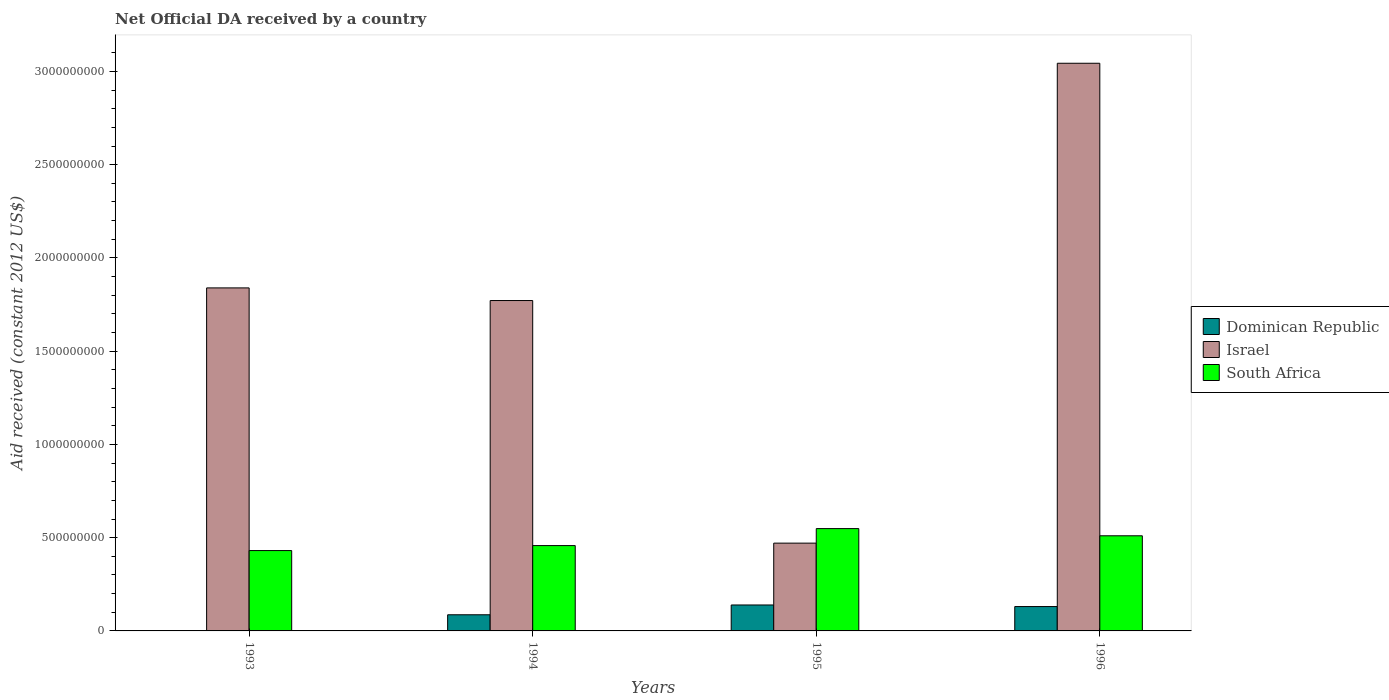How many different coloured bars are there?
Make the answer very short. 3. Are the number of bars per tick equal to the number of legend labels?
Your answer should be very brief. No. Are the number of bars on each tick of the X-axis equal?
Make the answer very short. No. How many bars are there on the 2nd tick from the right?
Your answer should be compact. 3. What is the label of the 4th group of bars from the left?
Give a very brief answer. 1996. In how many cases, is the number of bars for a given year not equal to the number of legend labels?
Give a very brief answer. 1. What is the net official development assistance aid received in Dominican Republic in 1993?
Your response must be concise. 0. Across all years, what is the maximum net official development assistance aid received in Dominican Republic?
Ensure brevity in your answer.  1.39e+08. What is the total net official development assistance aid received in South Africa in the graph?
Your answer should be very brief. 1.95e+09. What is the difference between the net official development assistance aid received in South Africa in 1995 and that in 1996?
Provide a short and direct response. 3.86e+07. What is the difference between the net official development assistance aid received in Dominican Republic in 1996 and the net official development assistance aid received in Israel in 1994?
Give a very brief answer. -1.64e+09. What is the average net official development assistance aid received in South Africa per year?
Provide a short and direct response. 4.87e+08. In the year 1996, what is the difference between the net official development assistance aid received in Israel and net official development assistance aid received in South Africa?
Give a very brief answer. 2.53e+09. What is the ratio of the net official development assistance aid received in South Africa in 1993 to that in 1994?
Ensure brevity in your answer.  0.94. What is the difference between the highest and the second highest net official development assistance aid received in South Africa?
Provide a succinct answer. 3.86e+07. What is the difference between the highest and the lowest net official development assistance aid received in South Africa?
Offer a very short reply. 1.18e+08. Is it the case that in every year, the sum of the net official development assistance aid received in Dominican Republic and net official development assistance aid received in Israel is greater than the net official development assistance aid received in South Africa?
Your answer should be very brief. Yes. Are the values on the major ticks of Y-axis written in scientific E-notation?
Your answer should be very brief. No. Does the graph contain any zero values?
Your answer should be very brief. Yes. Does the graph contain grids?
Give a very brief answer. No. Where does the legend appear in the graph?
Offer a terse response. Center right. How are the legend labels stacked?
Your answer should be compact. Vertical. What is the title of the graph?
Provide a succinct answer. Net Official DA received by a country. What is the label or title of the X-axis?
Your response must be concise. Years. What is the label or title of the Y-axis?
Make the answer very short. Aid received (constant 2012 US$). What is the Aid received (constant 2012 US$) of Dominican Republic in 1993?
Ensure brevity in your answer.  0. What is the Aid received (constant 2012 US$) of Israel in 1993?
Your answer should be very brief. 1.84e+09. What is the Aid received (constant 2012 US$) in South Africa in 1993?
Ensure brevity in your answer.  4.31e+08. What is the Aid received (constant 2012 US$) of Dominican Republic in 1994?
Your answer should be compact. 8.66e+07. What is the Aid received (constant 2012 US$) of Israel in 1994?
Keep it short and to the point. 1.77e+09. What is the Aid received (constant 2012 US$) of South Africa in 1994?
Provide a short and direct response. 4.58e+08. What is the Aid received (constant 2012 US$) of Dominican Republic in 1995?
Give a very brief answer. 1.39e+08. What is the Aid received (constant 2012 US$) of Israel in 1995?
Your answer should be compact. 4.71e+08. What is the Aid received (constant 2012 US$) in South Africa in 1995?
Offer a very short reply. 5.49e+08. What is the Aid received (constant 2012 US$) of Dominican Republic in 1996?
Your response must be concise. 1.31e+08. What is the Aid received (constant 2012 US$) of Israel in 1996?
Offer a very short reply. 3.04e+09. What is the Aid received (constant 2012 US$) in South Africa in 1996?
Provide a succinct answer. 5.10e+08. Across all years, what is the maximum Aid received (constant 2012 US$) in Dominican Republic?
Your answer should be very brief. 1.39e+08. Across all years, what is the maximum Aid received (constant 2012 US$) in Israel?
Your answer should be very brief. 3.04e+09. Across all years, what is the maximum Aid received (constant 2012 US$) in South Africa?
Give a very brief answer. 5.49e+08. Across all years, what is the minimum Aid received (constant 2012 US$) in Israel?
Your answer should be very brief. 4.71e+08. Across all years, what is the minimum Aid received (constant 2012 US$) in South Africa?
Provide a succinct answer. 4.31e+08. What is the total Aid received (constant 2012 US$) of Dominican Republic in the graph?
Offer a terse response. 3.56e+08. What is the total Aid received (constant 2012 US$) in Israel in the graph?
Your answer should be compact. 7.13e+09. What is the total Aid received (constant 2012 US$) in South Africa in the graph?
Your answer should be very brief. 1.95e+09. What is the difference between the Aid received (constant 2012 US$) in Israel in 1993 and that in 1994?
Provide a short and direct response. 6.78e+07. What is the difference between the Aid received (constant 2012 US$) of South Africa in 1993 and that in 1994?
Offer a terse response. -2.67e+07. What is the difference between the Aid received (constant 2012 US$) of Israel in 1993 and that in 1995?
Ensure brevity in your answer.  1.37e+09. What is the difference between the Aid received (constant 2012 US$) in South Africa in 1993 and that in 1995?
Your answer should be compact. -1.18e+08. What is the difference between the Aid received (constant 2012 US$) of Israel in 1993 and that in 1996?
Offer a very short reply. -1.20e+09. What is the difference between the Aid received (constant 2012 US$) in South Africa in 1993 and that in 1996?
Give a very brief answer. -7.92e+07. What is the difference between the Aid received (constant 2012 US$) in Dominican Republic in 1994 and that in 1995?
Provide a succinct answer. -5.26e+07. What is the difference between the Aid received (constant 2012 US$) of Israel in 1994 and that in 1995?
Provide a short and direct response. 1.30e+09. What is the difference between the Aid received (constant 2012 US$) of South Africa in 1994 and that in 1995?
Offer a terse response. -9.11e+07. What is the difference between the Aid received (constant 2012 US$) in Dominican Republic in 1994 and that in 1996?
Keep it short and to the point. -4.40e+07. What is the difference between the Aid received (constant 2012 US$) in Israel in 1994 and that in 1996?
Offer a very short reply. -1.27e+09. What is the difference between the Aid received (constant 2012 US$) of South Africa in 1994 and that in 1996?
Provide a short and direct response. -5.25e+07. What is the difference between the Aid received (constant 2012 US$) of Dominican Republic in 1995 and that in 1996?
Provide a short and direct response. 8.52e+06. What is the difference between the Aid received (constant 2012 US$) in Israel in 1995 and that in 1996?
Your response must be concise. -2.57e+09. What is the difference between the Aid received (constant 2012 US$) of South Africa in 1995 and that in 1996?
Your answer should be very brief. 3.86e+07. What is the difference between the Aid received (constant 2012 US$) in Israel in 1993 and the Aid received (constant 2012 US$) in South Africa in 1994?
Give a very brief answer. 1.38e+09. What is the difference between the Aid received (constant 2012 US$) of Israel in 1993 and the Aid received (constant 2012 US$) of South Africa in 1995?
Your response must be concise. 1.29e+09. What is the difference between the Aid received (constant 2012 US$) in Israel in 1993 and the Aid received (constant 2012 US$) in South Africa in 1996?
Provide a succinct answer. 1.33e+09. What is the difference between the Aid received (constant 2012 US$) in Dominican Republic in 1994 and the Aid received (constant 2012 US$) in Israel in 1995?
Keep it short and to the point. -3.84e+08. What is the difference between the Aid received (constant 2012 US$) in Dominican Republic in 1994 and the Aid received (constant 2012 US$) in South Africa in 1995?
Your answer should be compact. -4.62e+08. What is the difference between the Aid received (constant 2012 US$) in Israel in 1994 and the Aid received (constant 2012 US$) in South Africa in 1995?
Make the answer very short. 1.22e+09. What is the difference between the Aid received (constant 2012 US$) in Dominican Republic in 1994 and the Aid received (constant 2012 US$) in Israel in 1996?
Your answer should be very brief. -2.96e+09. What is the difference between the Aid received (constant 2012 US$) of Dominican Republic in 1994 and the Aid received (constant 2012 US$) of South Africa in 1996?
Offer a very short reply. -4.24e+08. What is the difference between the Aid received (constant 2012 US$) of Israel in 1994 and the Aid received (constant 2012 US$) of South Africa in 1996?
Your answer should be very brief. 1.26e+09. What is the difference between the Aid received (constant 2012 US$) in Dominican Republic in 1995 and the Aid received (constant 2012 US$) in Israel in 1996?
Your response must be concise. -2.90e+09. What is the difference between the Aid received (constant 2012 US$) in Dominican Republic in 1995 and the Aid received (constant 2012 US$) in South Africa in 1996?
Offer a very short reply. -3.71e+08. What is the difference between the Aid received (constant 2012 US$) in Israel in 1995 and the Aid received (constant 2012 US$) in South Africa in 1996?
Your answer should be very brief. -3.94e+07. What is the average Aid received (constant 2012 US$) in Dominican Republic per year?
Your response must be concise. 8.91e+07. What is the average Aid received (constant 2012 US$) of Israel per year?
Offer a terse response. 1.78e+09. What is the average Aid received (constant 2012 US$) of South Africa per year?
Your answer should be very brief. 4.87e+08. In the year 1993, what is the difference between the Aid received (constant 2012 US$) in Israel and Aid received (constant 2012 US$) in South Africa?
Your answer should be very brief. 1.41e+09. In the year 1994, what is the difference between the Aid received (constant 2012 US$) of Dominican Republic and Aid received (constant 2012 US$) of Israel?
Give a very brief answer. -1.68e+09. In the year 1994, what is the difference between the Aid received (constant 2012 US$) in Dominican Republic and Aid received (constant 2012 US$) in South Africa?
Give a very brief answer. -3.71e+08. In the year 1994, what is the difference between the Aid received (constant 2012 US$) in Israel and Aid received (constant 2012 US$) in South Africa?
Provide a short and direct response. 1.31e+09. In the year 1995, what is the difference between the Aid received (constant 2012 US$) of Dominican Republic and Aid received (constant 2012 US$) of Israel?
Provide a succinct answer. -3.32e+08. In the year 1995, what is the difference between the Aid received (constant 2012 US$) of Dominican Republic and Aid received (constant 2012 US$) of South Africa?
Offer a terse response. -4.10e+08. In the year 1995, what is the difference between the Aid received (constant 2012 US$) in Israel and Aid received (constant 2012 US$) in South Africa?
Your answer should be very brief. -7.80e+07. In the year 1996, what is the difference between the Aid received (constant 2012 US$) of Dominican Republic and Aid received (constant 2012 US$) of Israel?
Provide a succinct answer. -2.91e+09. In the year 1996, what is the difference between the Aid received (constant 2012 US$) in Dominican Republic and Aid received (constant 2012 US$) in South Africa?
Make the answer very short. -3.79e+08. In the year 1996, what is the difference between the Aid received (constant 2012 US$) of Israel and Aid received (constant 2012 US$) of South Africa?
Your response must be concise. 2.53e+09. What is the ratio of the Aid received (constant 2012 US$) in Israel in 1993 to that in 1994?
Keep it short and to the point. 1.04. What is the ratio of the Aid received (constant 2012 US$) in South Africa in 1993 to that in 1994?
Your response must be concise. 0.94. What is the ratio of the Aid received (constant 2012 US$) in Israel in 1993 to that in 1995?
Your response must be concise. 3.91. What is the ratio of the Aid received (constant 2012 US$) of South Africa in 1993 to that in 1995?
Give a very brief answer. 0.79. What is the ratio of the Aid received (constant 2012 US$) of Israel in 1993 to that in 1996?
Offer a terse response. 0.6. What is the ratio of the Aid received (constant 2012 US$) of South Africa in 1993 to that in 1996?
Offer a terse response. 0.84. What is the ratio of the Aid received (constant 2012 US$) of Dominican Republic in 1994 to that in 1995?
Offer a terse response. 0.62. What is the ratio of the Aid received (constant 2012 US$) of Israel in 1994 to that in 1995?
Provide a succinct answer. 3.76. What is the ratio of the Aid received (constant 2012 US$) of South Africa in 1994 to that in 1995?
Provide a succinct answer. 0.83. What is the ratio of the Aid received (constant 2012 US$) of Dominican Republic in 1994 to that in 1996?
Your answer should be compact. 0.66. What is the ratio of the Aid received (constant 2012 US$) of Israel in 1994 to that in 1996?
Provide a succinct answer. 0.58. What is the ratio of the Aid received (constant 2012 US$) of South Africa in 1994 to that in 1996?
Your answer should be very brief. 0.9. What is the ratio of the Aid received (constant 2012 US$) of Dominican Republic in 1995 to that in 1996?
Make the answer very short. 1.07. What is the ratio of the Aid received (constant 2012 US$) of Israel in 1995 to that in 1996?
Keep it short and to the point. 0.15. What is the ratio of the Aid received (constant 2012 US$) of South Africa in 1995 to that in 1996?
Your response must be concise. 1.08. What is the difference between the highest and the second highest Aid received (constant 2012 US$) of Dominican Republic?
Make the answer very short. 8.52e+06. What is the difference between the highest and the second highest Aid received (constant 2012 US$) of Israel?
Your answer should be very brief. 1.20e+09. What is the difference between the highest and the second highest Aid received (constant 2012 US$) in South Africa?
Ensure brevity in your answer.  3.86e+07. What is the difference between the highest and the lowest Aid received (constant 2012 US$) of Dominican Republic?
Your response must be concise. 1.39e+08. What is the difference between the highest and the lowest Aid received (constant 2012 US$) in Israel?
Ensure brevity in your answer.  2.57e+09. What is the difference between the highest and the lowest Aid received (constant 2012 US$) of South Africa?
Ensure brevity in your answer.  1.18e+08. 